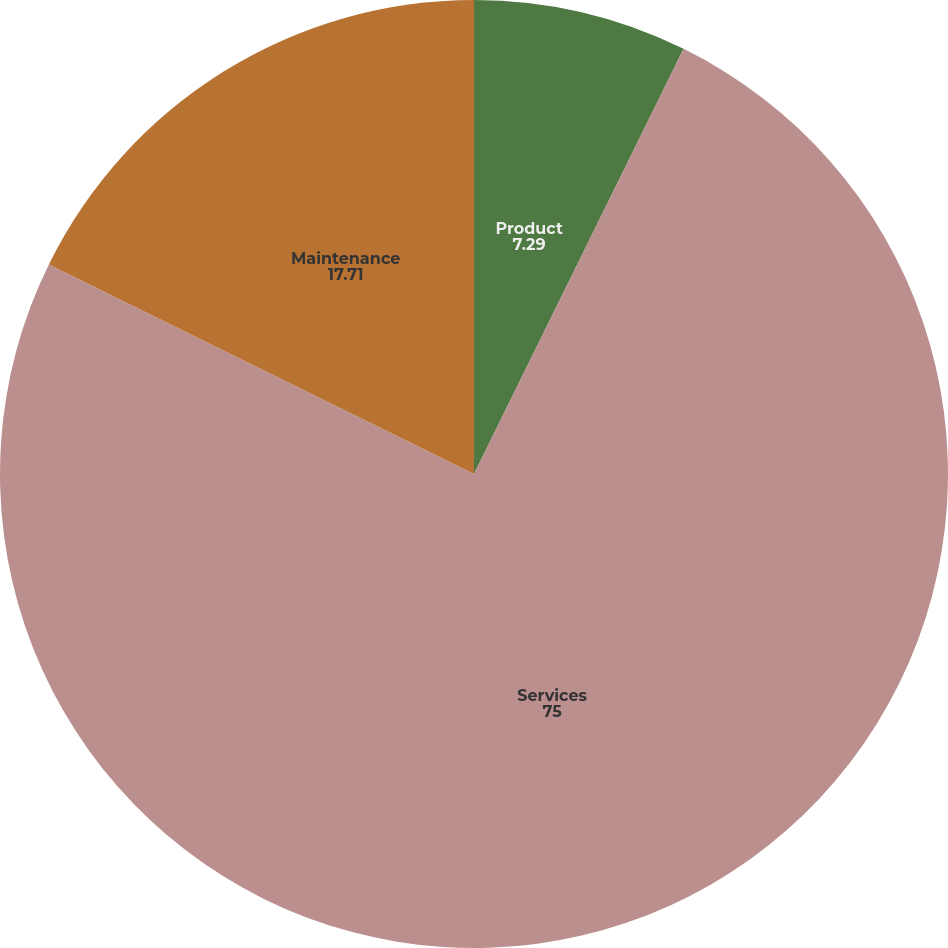<chart> <loc_0><loc_0><loc_500><loc_500><pie_chart><fcel>Product<fcel>Services<fcel>Maintenance<nl><fcel>7.29%<fcel>75.0%<fcel>17.71%<nl></chart> 